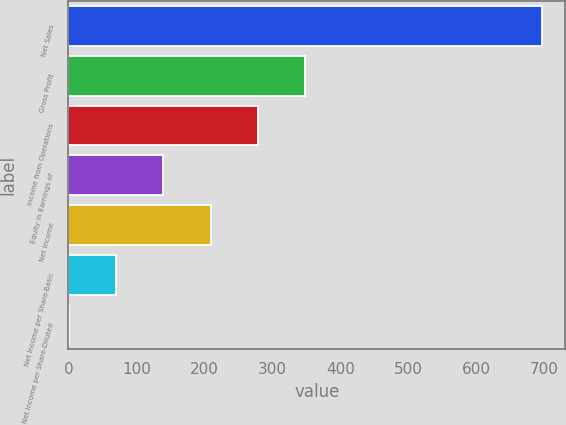<chart> <loc_0><loc_0><loc_500><loc_500><bar_chart><fcel>Net Sales<fcel>Gross Profit<fcel>Income from Operations<fcel>Equity in Earnings of<fcel>Net Income<fcel>Net Income per Share-Basic<fcel>Net Income per Share-Diluted<nl><fcel>696.4<fcel>348.46<fcel>278.88<fcel>139.72<fcel>209.3<fcel>70.14<fcel>0.56<nl></chart> 